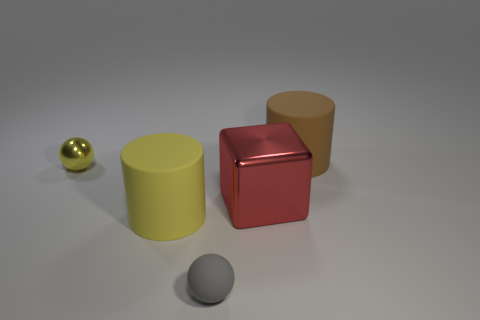Add 2 large objects. How many objects exist? 7 Subtract all cylinders. How many objects are left? 3 Subtract 0 green blocks. How many objects are left? 5 Subtract all tiny gray rubber cubes. Subtract all small gray objects. How many objects are left? 4 Add 1 big red metallic things. How many big red metallic things are left? 2 Add 1 small metal things. How many small metal things exist? 2 